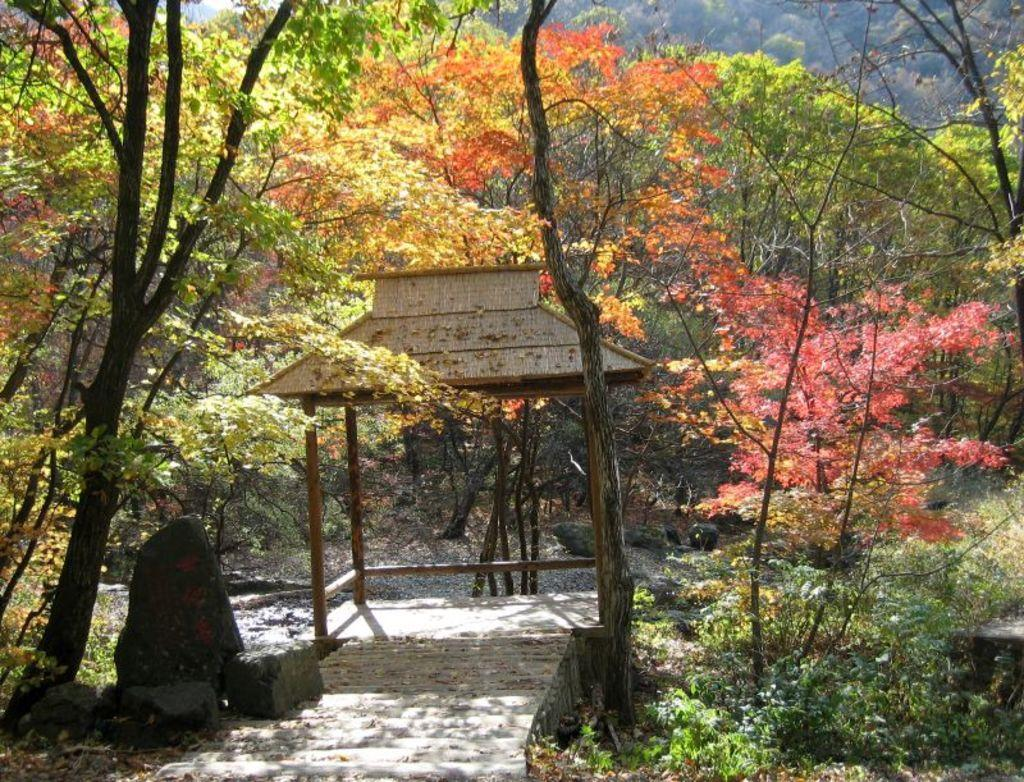What type of structure is in the image? There is a wooden shelter in the image. What material are the poles of the wooden shelter made of? The wooden shelter has wooden poles. What can be seen around the wooden shelter? There are trees around the wooden shelter. What else is present near the trees? There are rocks near the trees. What type of sponge is hanging on the wooden poles of the shelter? There is no sponge present in the image; the wooden shelter has wooden poles. What shape is the calendar that is lying on the ground near the shelter? There is no calendar present in the image; the image only features a wooden shelter, trees, and rocks. 